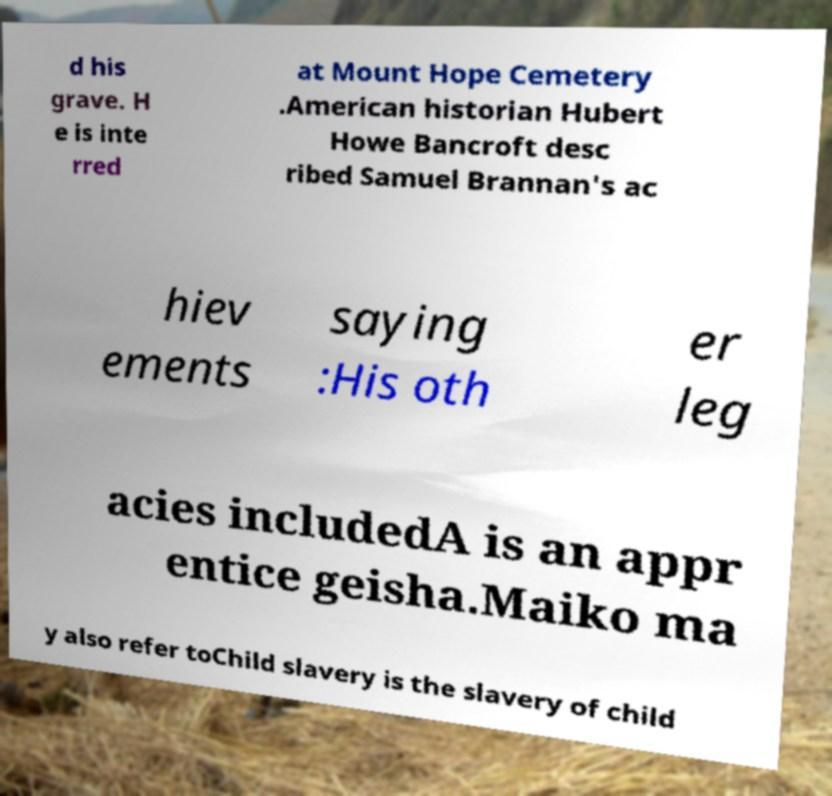Could you assist in decoding the text presented in this image and type it out clearly? d his grave. H e is inte rred at Mount Hope Cemetery .American historian Hubert Howe Bancroft desc ribed Samuel Brannan's ac hiev ements saying :His oth er leg acies includedA is an appr entice geisha.Maiko ma y also refer toChild slavery is the slavery of child 